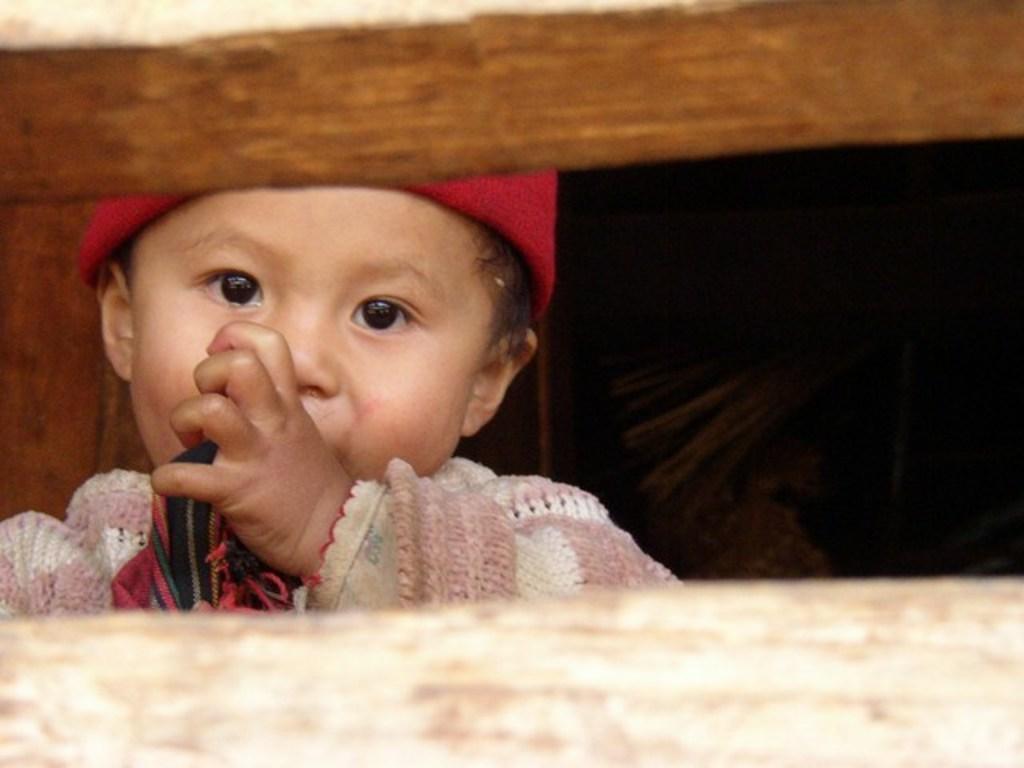How would you summarize this image in a sentence or two? This image is taken outdoors. In the middle of the image there is a kid. He has worn a sweater, a scarf and a cap. At the bottom of the image there is a wooden fencing. 